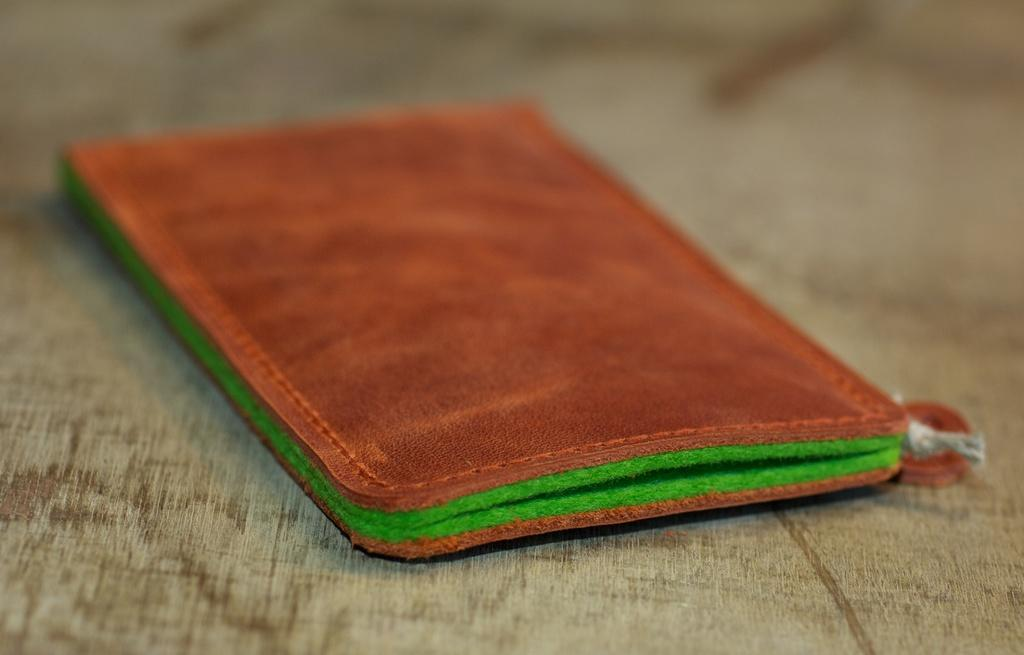What type of object is in the image? There is a leather wallet-like object in the image. Where is the object placed in the image? The object is on a wooden surface. How close is the object to the viewer in the image? The object is in the foreground of the image. Can you see a nest in the image? There is no nest present in the image. What angle is the image taken from? The angle from which the image is taken is not mentioned in the provided facts, so it cannot be determined. 